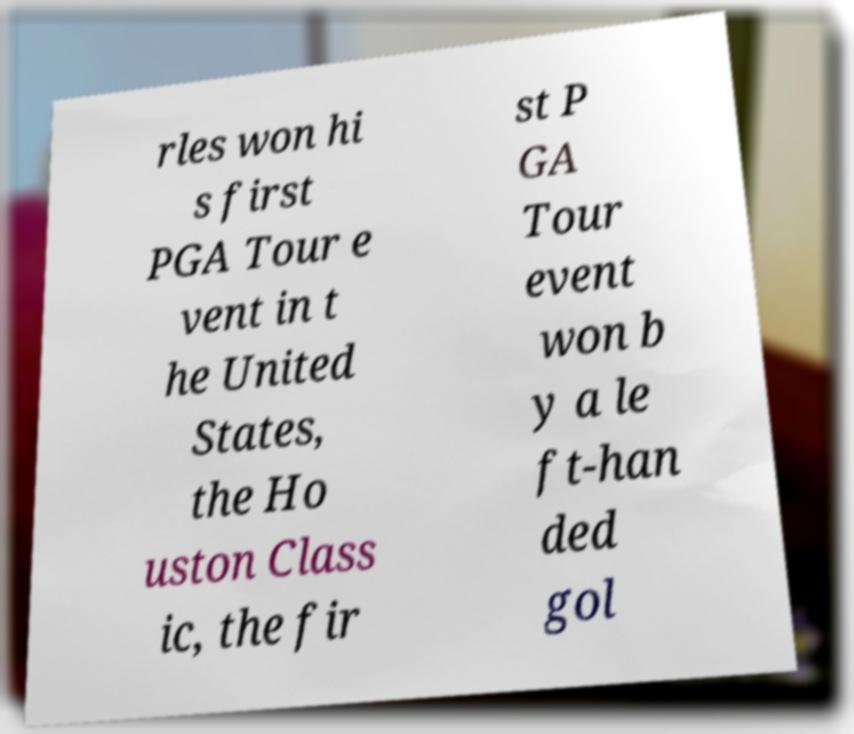There's text embedded in this image that I need extracted. Can you transcribe it verbatim? rles won hi s first PGA Tour e vent in t he United States, the Ho uston Class ic, the fir st P GA Tour event won b y a le ft-han ded gol 